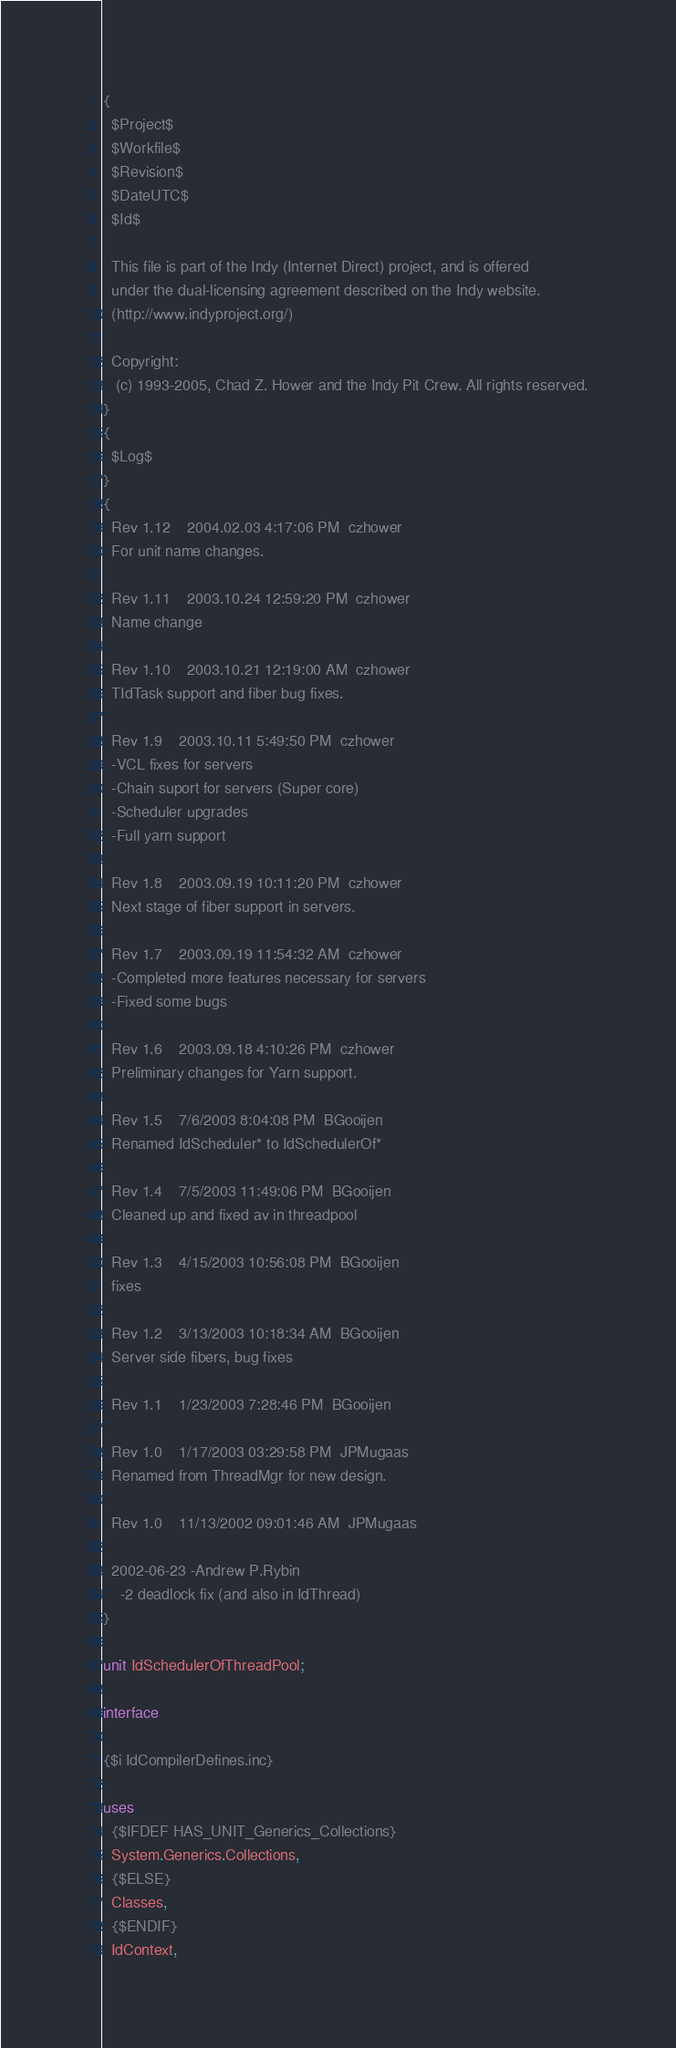Convert code to text. <code><loc_0><loc_0><loc_500><loc_500><_Pascal_>{
  $Project$
  $Workfile$
  $Revision$
  $DateUTC$
  $Id$

  This file is part of the Indy (Internet Direct) project, and is offered
  under the dual-licensing agreement described on the Indy website.
  (http://www.indyproject.org/)

  Copyright:
   (c) 1993-2005, Chad Z. Hower and the Indy Pit Crew. All rights reserved.
}
{
  $Log$
}
{
  Rev 1.12    2004.02.03 4:17:06 PM  czhower
  For unit name changes.

  Rev 1.11    2003.10.24 12:59:20 PM  czhower
  Name change

  Rev 1.10    2003.10.21 12:19:00 AM  czhower
  TIdTask support and fiber bug fixes.

  Rev 1.9    2003.10.11 5:49:50 PM  czhower
  -VCL fixes for servers
  -Chain suport for servers (Super core)
  -Scheduler upgrades
  -Full yarn support

  Rev 1.8    2003.09.19 10:11:20 PM  czhower
  Next stage of fiber support in servers.

  Rev 1.7    2003.09.19 11:54:32 AM  czhower
  -Completed more features necessary for servers
  -Fixed some bugs

  Rev 1.6    2003.09.18 4:10:26 PM  czhower
  Preliminary changes for Yarn support.

  Rev 1.5    7/6/2003 8:04:08 PM  BGooijen
  Renamed IdScheduler* to IdSchedulerOf*

  Rev 1.4    7/5/2003 11:49:06 PM  BGooijen
  Cleaned up and fixed av in threadpool

  Rev 1.3    4/15/2003 10:56:08 PM  BGooijen
  fixes

  Rev 1.2    3/13/2003 10:18:34 AM  BGooijen
  Server side fibers, bug fixes

  Rev 1.1    1/23/2003 7:28:46 PM  BGooijen

  Rev 1.0    1/17/2003 03:29:58 PM  JPMugaas
  Renamed from ThreadMgr for new design.

  Rev 1.0    11/13/2002 09:01:46 AM  JPMugaas

  2002-06-23 -Andrew P.Rybin
    -2 deadlock fix (and also in IdThread)
}

unit IdSchedulerOfThreadPool;

interface

{$i IdCompilerDefines.inc}

uses
  {$IFDEF HAS_UNIT_Generics_Collections}
  System.Generics.Collections,
  {$ELSE}
  Classes,
  {$ENDIF}
  IdContext,</code> 